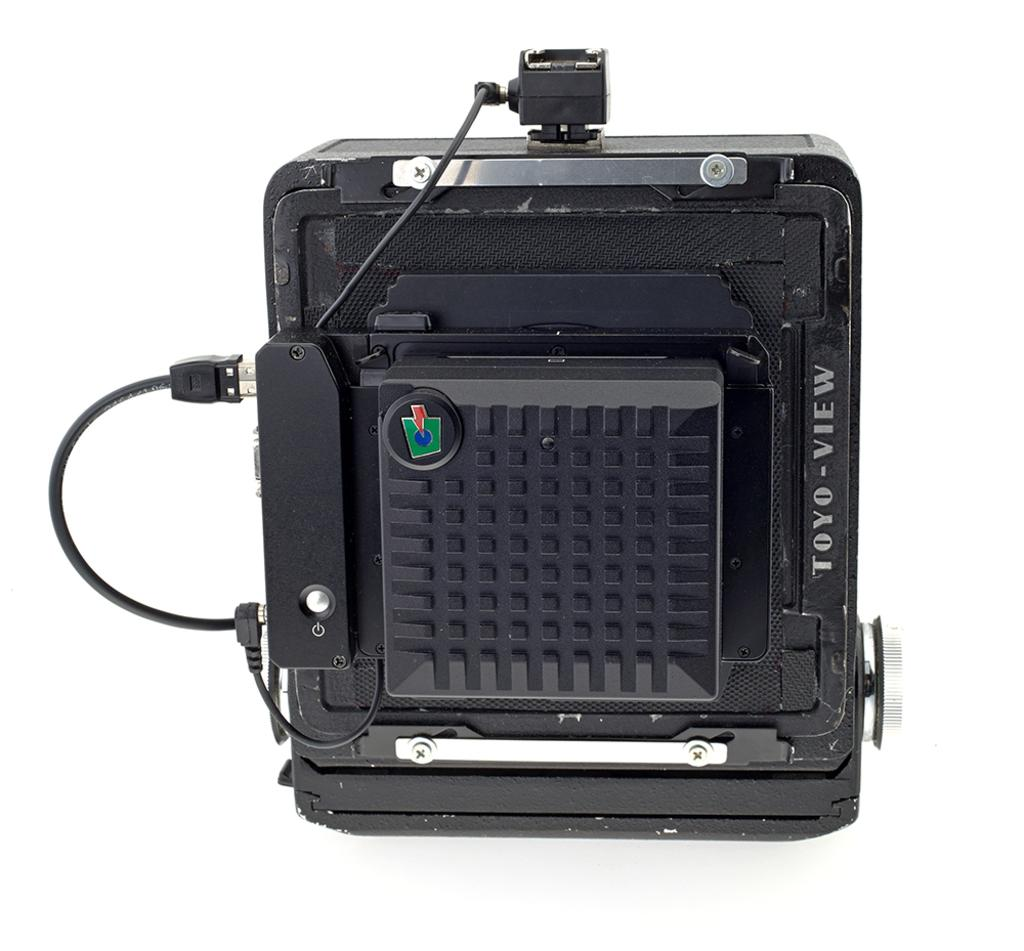What is the color of the machine in the image? The machine in the image is black. Can you describe the machine in more detail? Unfortunately, the provided facts only mention the color of the machine, so we cannot provide more details about its appearance or function. How many ducks are sitting on the machine in the image? There are no ducks present in the image; it only features a black color machine. What type of copy is being made by the machine in the image? The provided facts do not mention any copying or printing function of the machine, so we cannot answer this question. 